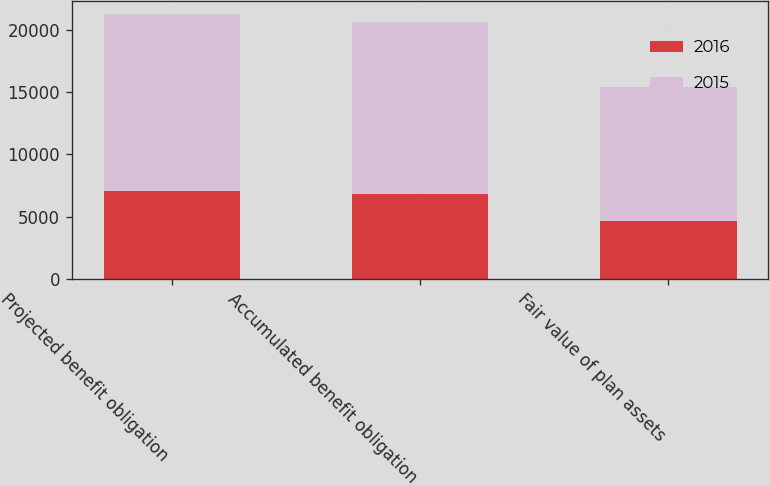Convert chart. <chart><loc_0><loc_0><loc_500><loc_500><stacked_bar_chart><ecel><fcel>Projected benefit obligation<fcel>Accumulated benefit obligation<fcel>Fair value of plan assets<nl><fcel>2016<fcel>7026<fcel>6850<fcel>4629<nl><fcel>2015<fcel>14247<fcel>13832<fcel>10786<nl></chart> 